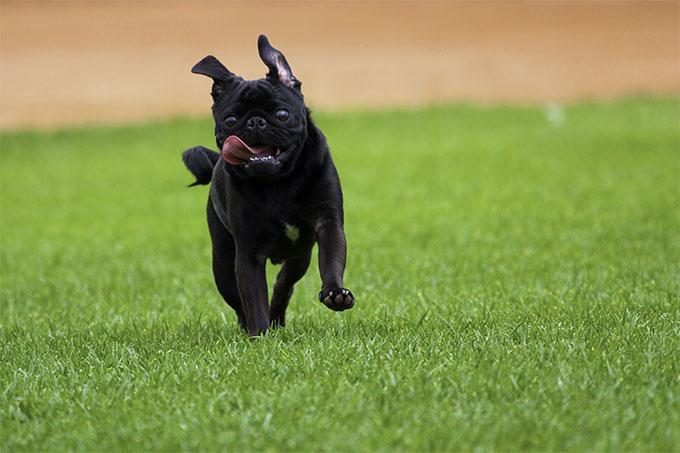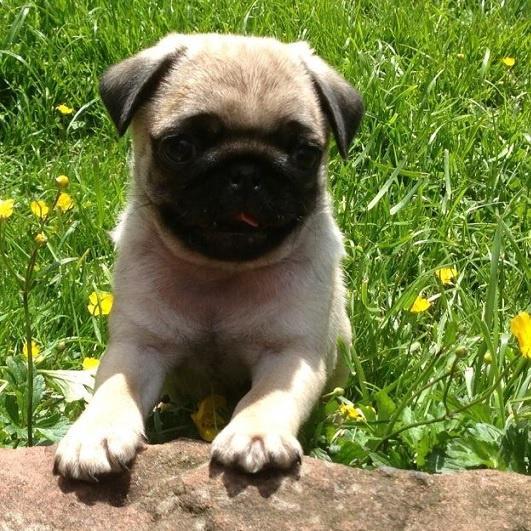The first image is the image on the left, the second image is the image on the right. For the images shown, is this caption "There are two dogs in the image on the left." true? Answer yes or no. No. 